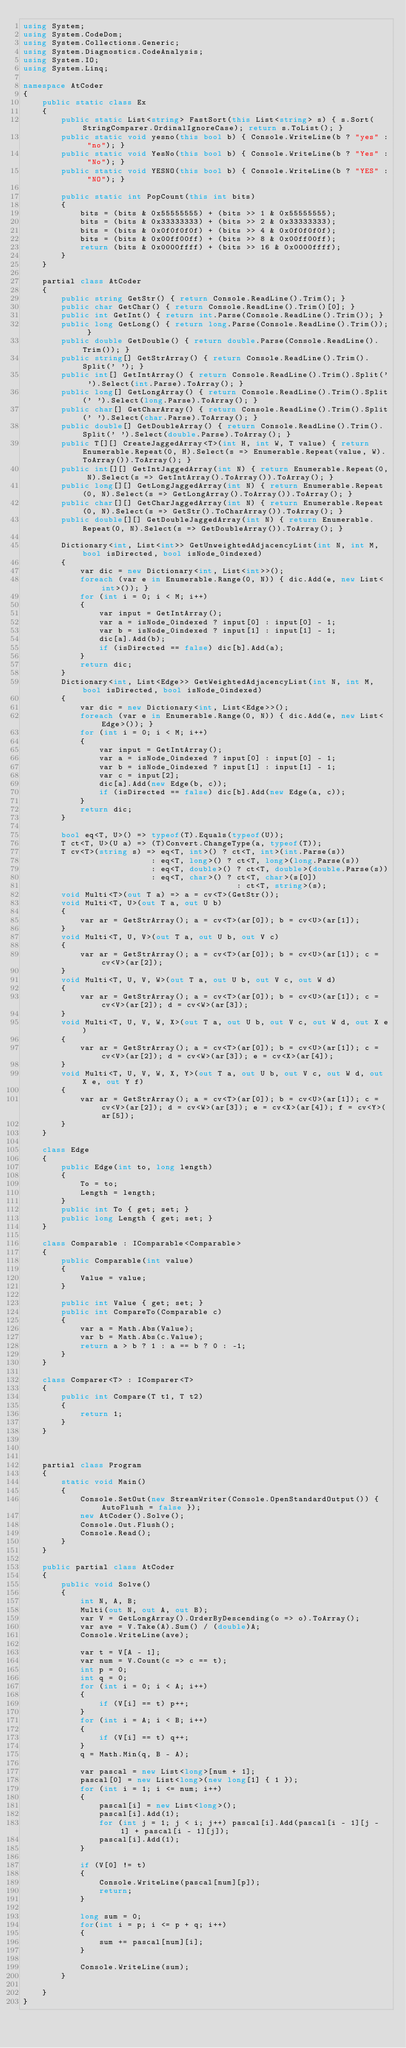<code> <loc_0><loc_0><loc_500><loc_500><_C#_>using System;
using System.CodeDom;
using System.Collections.Generic;
using System.Diagnostics.CodeAnalysis;
using System.IO;
using System.Linq;

namespace AtCoder
{
    public static class Ex
    {
        public static List<string> FastSort(this List<string> s) { s.Sort(StringComparer.OrdinalIgnoreCase); return s.ToList(); }
        public static void yesno(this bool b) { Console.WriteLine(b ? "yes" : "no"); }
        public static void YesNo(this bool b) { Console.WriteLine(b ? "Yes" : "No"); }
        public static void YESNO(this bool b) { Console.WriteLine(b ? "YES" : "NO"); }

        public static int PopCount(this int bits)
        {
            bits = (bits & 0x55555555) + (bits >> 1 & 0x55555555);
            bits = (bits & 0x33333333) + (bits >> 2 & 0x33333333);
            bits = (bits & 0x0f0f0f0f) + (bits >> 4 & 0x0f0f0f0f);
            bits = (bits & 0x00ff00ff) + (bits >> 8 & 0x00ff00ff);
            return (bits & 0x0000ffff) + (bits >> 16 & 0x0000ffff);
        }
    }

    partial class AtCoder
    {
        public string GetStr() { return Console.ReadLine().Trim(); }
        public char GetChar() { return Console.ReadLine().Trim()[0]; }
        public int GetInt() { return int.Parse(Console.ReadLine().Trim()); }
        public long GetLong() { return long.Parse(Console.ReadLine().Trim()); }
        public double GetDouble() { return double.Parse(Console.ReadLine().Trim()); }
        public string[] GetStrArray() { return Console.ReadLine().Trim().Split(' '); }
        public int[] GetIntArray() { return Console.ReadLine().Trim().Split(' ').Select(int.Parse).ToArray(); }
        public long[] GetLongArray() { return Console.ReadLine().Trim().Split(' ').Select(long.Parse).ToArray(); }
        public char[] GetCharArray() { return Console.ReadLine().Trim().Split(' ').Select(char.Parse).ToArray(); }
        public double[] GetDoubleArray() { return Console.ReadLine().Trim().Split(' ').Select(double.Parse).ToArray(); }
        public T[][] CreateJaggedArray<T>(int H, int W, T value) { return Enumerable.Repeat(0, H).Select(s => Enumerable.Repeat(value, W).ToArray()).ToArray(); }
        public int[][] GetIntJaggedArray(int N) { return Enumerable.Repeat(0, N).Select(s => GetIntArray().ToArray()).ToArray(); }
        public long[][] GetLongJaggedArray(int N) { return Enumerable.Repeat(0, N).Select(s => GetLongArray().ToArray()).ToArray(); }
        public char[][] GetCharJaggedArray(int N) { return Enumerable.Repeat(0, N).Select(s => GetStr().ToCharArray()).ToArray(); }
        public double[][] GetDoubleJaggedArray(int N) { return Enumerable.Repeat(0, N).Select(s => GetDoubleArray()).ToArray(); }

        Dictionary<int, List<int>> GetUnweightedAdjacencyList(int N, int M, bool isDirected, bool isNode_0indexed)
        {
            var dic = new Dictionary<int, List<int>>();
            foreach (var e in Enumerable.Range(0, N)) { dic.Add(e, new List<int>()); }
            for (int i = 0; i < M; i++)
            {
                var input = GetIntArray();
                var a = isNode_0indexed ? input[0] : input[0] - 1;
                var b = isNode_0indexed ? input[1] : input[1] - 1;
                dic[a].Add(b);
                if (isDirected == false) dic[b].Add(a);
            }
            return dic;
        }
        Dictionary<int, List<Edge>> GetWeightedAdjacencyList(int N, int M, bool isDirected, bool isNode_0indexed)
        {
            var dic = new Dictionary<int, List<Edge>>();
            foreach (var e in Enumerable.Range(0, N)) { dic.Add(e, new List<Edge>()); }
            for (int i = 0; i < M; i++)
            {
                var input = GetIntArray();
                var a = isNode_0indexed ? input[0] : input[0] - 1;
                var b = isNode_0indexed ? input[1] : input[1] - 1;
                var c = input[2];
                dic[a].Add(new Edge(b, c));
                if (isDirected == false) dic[b].Add(new Edge(a, c));
            }
            return dic;
        }

        bool eq<T, U>() => typeof(T).Equals(typeof(U));
        T ct<T, U>(U a) => (T)Convert.ChangeType(a, typeof(T));
        T cv<T>(string s) => eq<T, int>() ? ct<T, int>(int.Parse(s))
                           : eq<T, long>() ? ct<T, long>(long.Parse(s))
                           : eq<T, double>() ? ct<T, double>(double.Parse(s))
                           : eq<T, char>() ? ct<T, char>(s[0])
                                             : ct<T, string>(s);
        void Multi<T>(out T a) => a = cv<T>(GetStr());
        void Multi<T, U>(out T a, out U b)
        {
            var ar = GetStrArray(); a = cv<T>(ar[0]); b = cv<U>(ar[1]);
        }
        void Multi<T, U, V>(out T a, out U b, out V c)
        {
            var ar = GetStrArray(); a = cv<T>(ar[0]); b = cv<U>(ar[1]); c = cv<V>(ar[2]);
        }
        void Multi<T, U, V, W>(out T a, out U b, out V c, out W d)
        {
            var ar = GetStrArray(); a = cv<T>(ar[0]); b = cv<U>(ar[1]); c = cv<V>(ar[2]); d = cv<W>(ar[3]);
        }
        void Multi<T, U, V, W, X>(out T a, out U b, out V c, out W d, out X e)
        {
            var ar = GetStrArray(); a = cv<T>(ar[0]); b = cv<U>(ar[1]); c = cv<V>(ar[2]); d = cv<W>(ar[3]); e = cv<X>(ar[4]);
        }
        void Multi<T, U, V, W, X, Y>(out T a, out U b, out V c, out W d, out X e, out Y f)
        {
            var ar = GetStrArray(); a = cv<T>(ar[0]); b = cv<U>(ar[1]); c = cv<V>(ar[2]); d = cv<W>(ar[3]); e = cv<X>(ar[4]); f = cv<Y>(ar[5]);
        }
    }

    class Edge
    {
        public Edge(int to, long length)
        {
            To = to;
            Length = length;
        }
        public int To { get; set; }
        public long Length { get; set; }
    }

    class Comparable : IComparable<Comparable>
    {
        public Comparable(int value)
        {
            Value = value;
        }

        public int Value { get; set; }
        public int CompareTo(Comparable c)
        {
            var a = Math.Abs(Value);
            var b = Math.Abs(c.Value);
            return a > b ? 1 : a == b ? 0 : -1;
        }
    }

    class Comparer<T> : IComparer<T>
    {
        public int Compare(T t1, T t2)
        {
            return 1;
        }
    }



    partial class Program
    {
        static void Main()
        {
            Console.SetOut(new StreamWriter(Console.OpenStandardOutput()) { AutoFlush = false });
            new AtCoder().Solve();
            Console.Out.Flush();
            Console.Read();
        }
    }

    public partial class AtCoder
    {
        public void Solve()
        {
            int N, A, B;
            Multi(out N, out A, out B);
            var V = GetLongArray().OrderByDescending(o => o).ToArray();
            var ave = V.Take(A).Sum() / (double)A;
            Console.WriteLine(ave);

            var t = V[A - 1];
            var num = V.Count(c => c == t);
            int p = 0;
            int q = 0;
            for (int i = 0; i < A; i++)
            {
                if (V[i] == t) p++;
            }
            for (int i = A; i < B; i++)
            {
                if (V[i] == t) q++;
            }
            q = Math.Min(q, B - A);

            var pascal = new List<long>[num + 1];
            pascal[0] = new List<long>(new long[1] { 1 });
            for (int i = 1; i <= num; i++)
            {
                pascal[i] = new List<long>();
                pascal[i].Add(1);
                for (int j = 1; j < i; j++) pascal[i].Add(pascal[i - 1][j - 1] + pascal[i - 1][j]);
                pascal[i].Add(1);
            }

            if (V[0] != t)
            {
                Console.WriteLine(pascal[num][p]);
                return;
            }

            long sum = 0;
            for(int i = p; i <= p + q; i++)
            {
                sum += pascal[num][i];
            }

            Console.WriteLine(sum);
        }

    }
}
</code> 